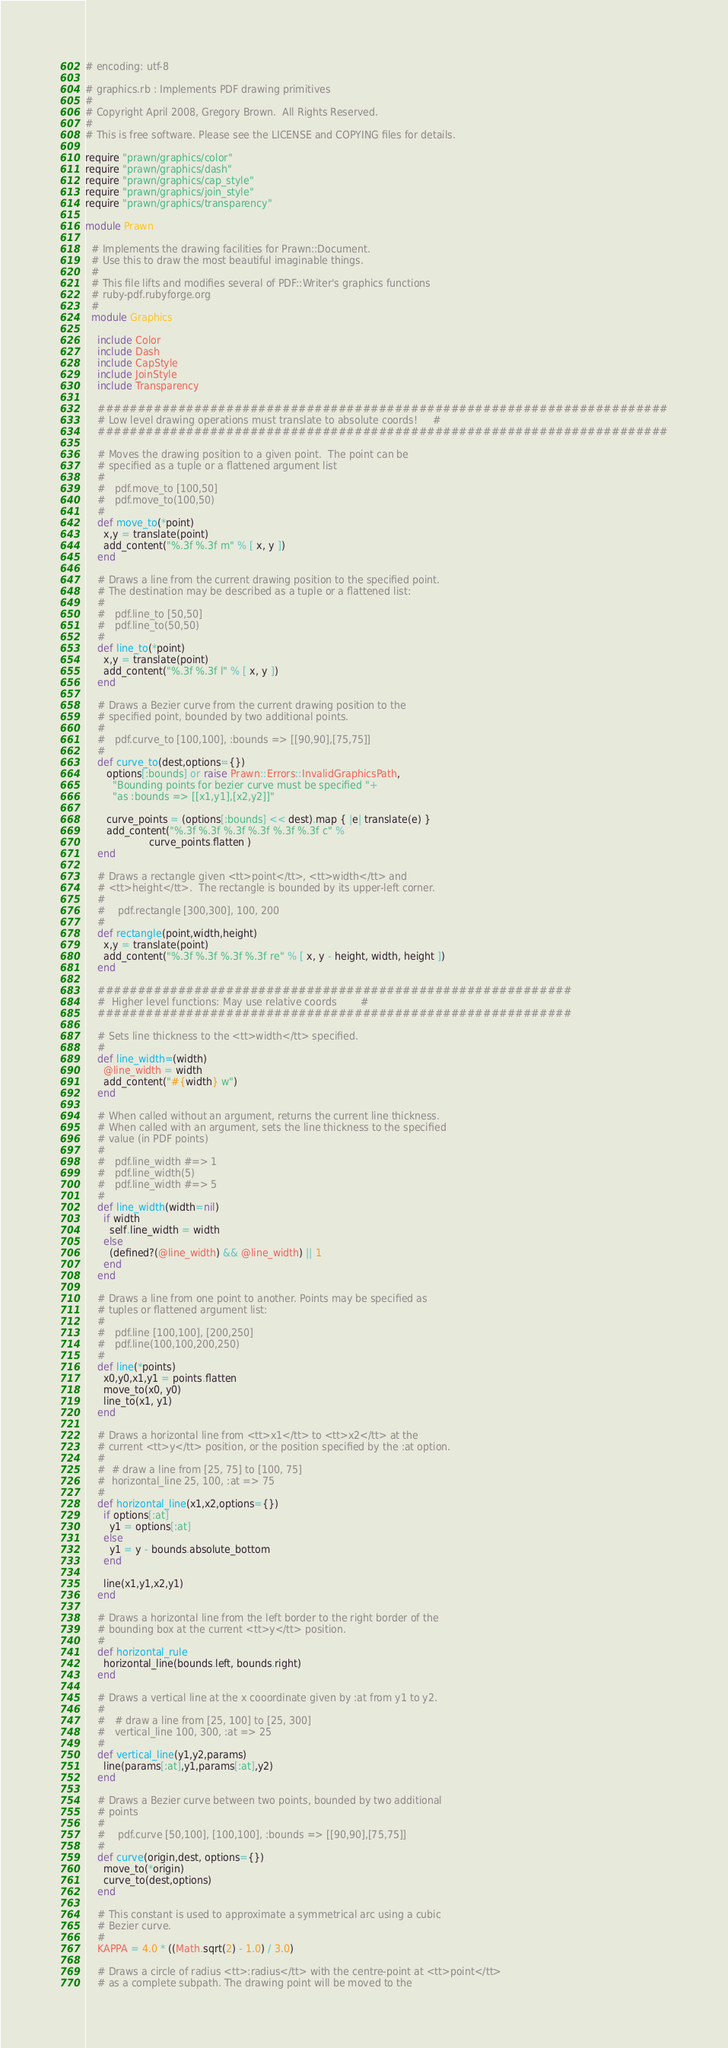<code> <loc_0><loc_0><loc_500><loc_500><_Ruby_># encoding: utf-8

# graphics.rb : Implements PDF drawing primitives
#
# Copyright April 2008, Gregory Brown.  All Rights Reserved.
#
# This is free software. Please see the LICENSE and COPYING files for details.

require "prawn/graphics/color"
require "prawn/graphics/dash"
require "prawn/graphics/cap_style"
require "prawn/graphics/join_style"
require "prawn/graphics/transparency"

module Prawn

  # Implements the drawing facilities for Prawn::Document.
  # Use this to draw the most beautiful imaginable things.
  #
  # This file lifts and modifies several of PDF::Writer's graphics functions
  # ruby-pdf.rubyforge.org
  #
  module Graphics

    include Color
    include Dash
    include CapStyle
    include JoinStyle
    include Transparency

    #######################################################################
    # Low level drawing operations must translate to absolute coords!     #
    #######################################################################

    # Moves the drawing position to a given point.  The point can be
    # specified as a tuple or a flattened argument list
    #
    #   pdf.move_to [100,50]
    #   pdf.move_to(100,50)
    #
    def move_to(*point)
      x,y = translate(point)
      add_content("%.3f %.3f m" % [ x, y ])
    end

    # Draws a line from the current drawing position to the specified point.
    # The destination may be described as a tuple or a flattened list:
    #
    #   pdf.line_to [50,50]
    #   pdf.line_to(50,50)
    #
    def line_to(*point)
      x,y = translate(point)
      add_content("%.3f %.3f l" % [ x, y ])
    end

    # Draws a Bezier curve from the current drawing position to the
    # specified point, bounded by two additional points.
    #
    #   pdf.curve_to [100,100], :bounds => [[90,90],[75,75]]
    #
    def curve_to(dest,options={})
       options[:bounds] or raise Prawn::Errors::InvalidGraphicsPath,
         "Bounding points for bezier curve must be specified "+
         "as :bounds => [[x1,y1],[x2,y2]]"

       curve_points = (options[:bounds] << dest).map { |e| translate(e) }
       add_content("%.3f %.3f %.3f %.3f %.3f %.3f c" %
                     curve_points.flatten )
    end

    # Draws a rectangle given <tt>point</tt>, <tt>width</tt> and
    # <tt>height</tt>.  The rectangle is bounded by its upper-left corner.
    #
    #    pdf.rectangle [300,300], 100, 200
    #
    def rectangle(point,width,height)
      x,y = translate(point)
      add_content("%.3f %.3f %.3f %.3f re" % [ x, y - height, width, height ])
    end

    ###########################################################
    #  Higher level functions: May use relative coords        #
    ###########################################################

    # Sets line thickness to the <tt>width</tt> specified.
    #
    def line_width=(width)
      @line_width = width
      add_content("#{width} w")
    end

    # When called without an argument, returns the current line thickness.
    # When called with an argument, sets the line thickness to the specified
    # value (in PDF points)
    #
    #   pdf.line_width #=> 1
    #   pdf.line_width(5)
    #   pdf.line_width #=> 5
    #
    def line_width(width=nil)
      if width
        self.line_width = width
      else
        (defined?(@line_width) && @line_width) || 1
      end
    end

    # Draws a line from one point to another. Points may be specified as
    # tuples or flattened argument list:
    #
    #   pdf.line [100,100], [200,250]
    #   pdf.line(100,100,200,250)
    #
    def line(*points)
      x0,y0,x1,y1 = points.flatten
      move_to(x0, y0)
      line_to(x1, y1)
    end

    # Draws a horizontal line from <tt>x1</tt> to <tt>x2</tt> at the
    # current <tt>y</tt> position, or the position specified by the :at option.
    #
    #  # draw a line from [25, 75] to [100, 75]
    #  horizontal_line 25, 100, :at => 75  
    #
    def horizontal_line(x1,x2,options={})
      if options[:at]
        y1 = options[:at]
      else
        y1 = y - bounds.absolute_bottom
      end
      
      line(x1,y1,x2,y1)
    end

    # Draws a horizontal line from the left border to the right border of the
    # bounding box at the current <tt>y</tt> position.
    #
    def horizontal_rule
      horizontal_line(bounds.left, bounds.right)
    end

    # Draws a vertical line at the x cooordinate given by :at from y1 to y2.
    #
    #   # draw a line from [25, 100] to [25, 300]
    #   vertical_line 100, 300, :at => 25
    #
    def vertical_line(y1,y2,params)
      line(params[:at],y1,params[:at],y2)
    end

    # Draws a Bezier curve between two points, bounded by two additional
    # points
    #
    #    pdf.curve [50,100], [100,100], :bounds => [[90,90],[75,75]]
    #
    def curve(origin,dest, options={})
      move_to(*origin)
      curve_to(dest,options)
    end

    # This constant is used to approximate a symmetrical arc using a cubic
    # Bezier curve.
    #
    KAPPA = 4.0 * ((Math.sqrt(2) - 1.0) / 3.0)

    # Draws a circle of radius <tt>:radius</tt> with the centre-point at <tt>point</tt>
    # as a complete subpath. The drawing point will be moved to the</code> 